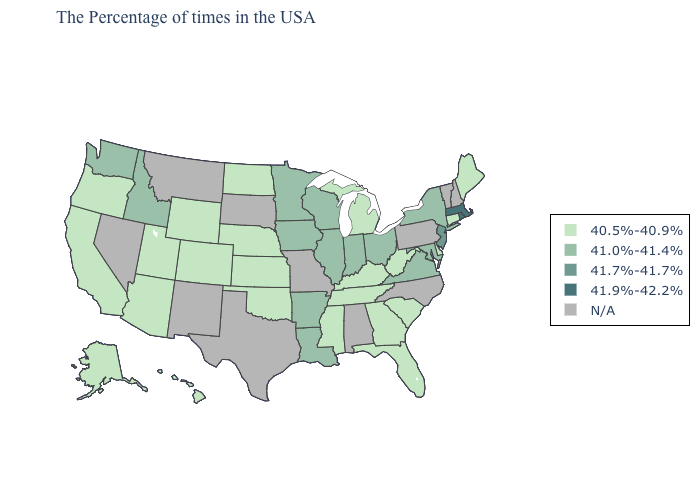What is the value of New Mexico?
Write a very short answer. N/A. Name the states that have a value in the range 41.0%-41.4%?
Be succinct. New York, Maryland, Virginia, Ohio, Indiana, Wisconsin, Illinois, Louisiana, Arkansas, Minnesota, Iowa, Idaho, Washington. Does the first symbol in the legend represent the smallest category?
Short answer required. Yes. Name the states that have a value in the range 40.5%-40.9%?
Short answer required. Maine, Connecticut, Delaware, South Carolina, West Virginia, Florida, Georgia, Michigan, Kentucky, Tennessee, Mississippi, Kansas, Nebraska, Oklahoma, North Dakota, Wyoming, Colorado, Utah, Arizona, California, Oregon, Alaska, Hawaii. What is the highest value in states that border Montana?
Short answer required. 41.0%-41.4%. Name the states that have a value in the range 41.9%-42.2%?
Short answer required. Massachusetts, Rhode Island. What is the value of New Mexico?
Answer briefly. N/A. What is the value of Connecticut?
Give a very brief answer. 40.5%-40.9%. How many symbols are there in the legend?
Short answer required. 5. What is the value of New York?
Short answer required. 41.0%-41.4%. What is the value of Michigan?
Give a very brief answer. 40.5%-40.9%. Among the states that border Rhode Island , does Connecticut have the lowest value?
Quick response, please. Yes. Among the states that border Utah , which have the highest value?
Give a very brief answer. Idaho. 